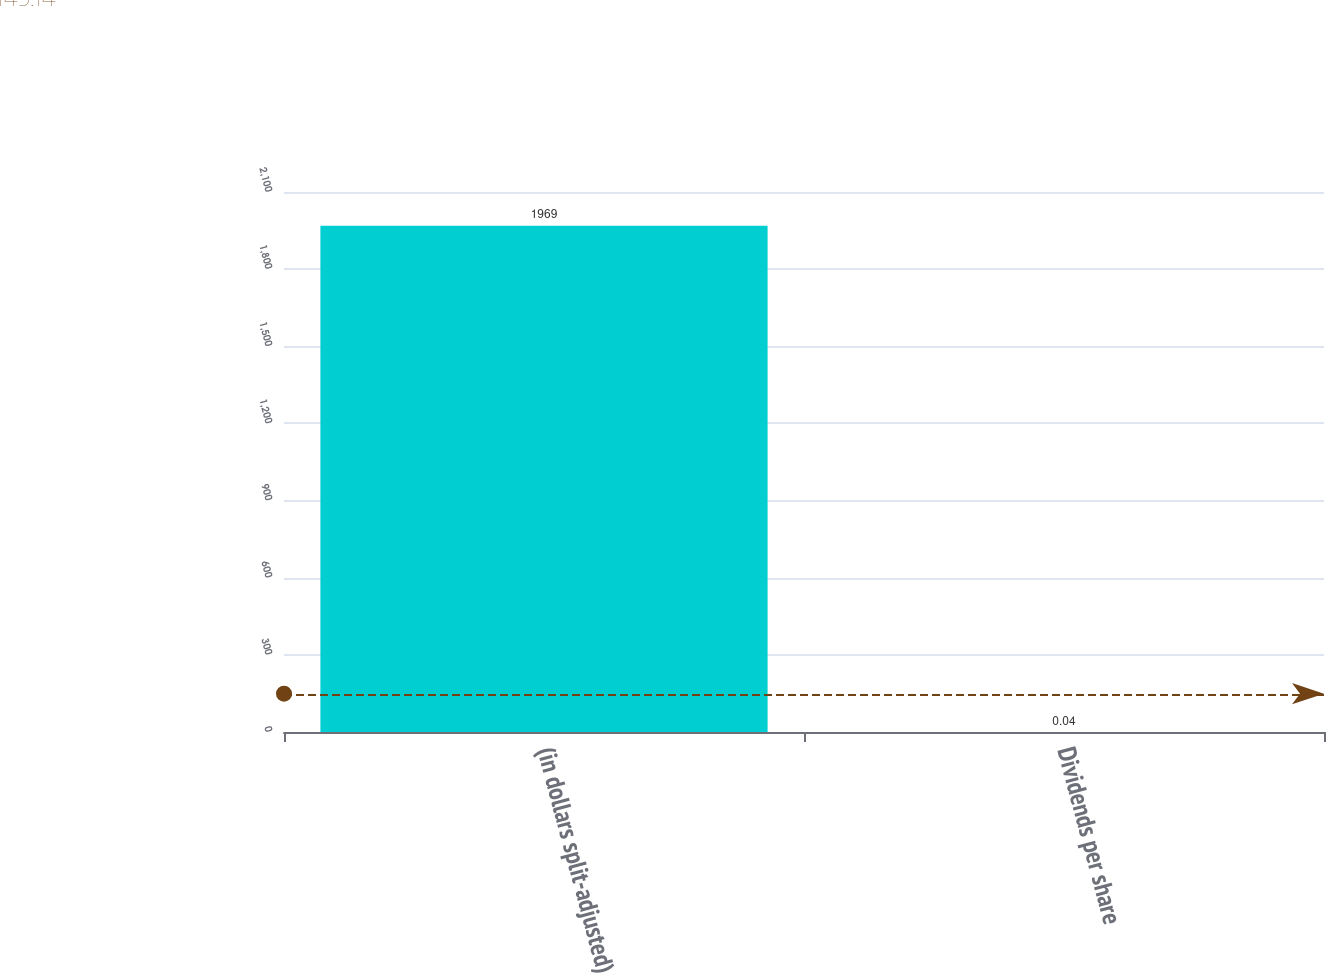Convert chart. <chart><loc_0><loc_0><loc_500><loc_500><bar_chart><fcel>(in dollars split-adjusted)<fcel>Dividends per share<nl><fcel>1969<fcel>0.04<nl></chart> 